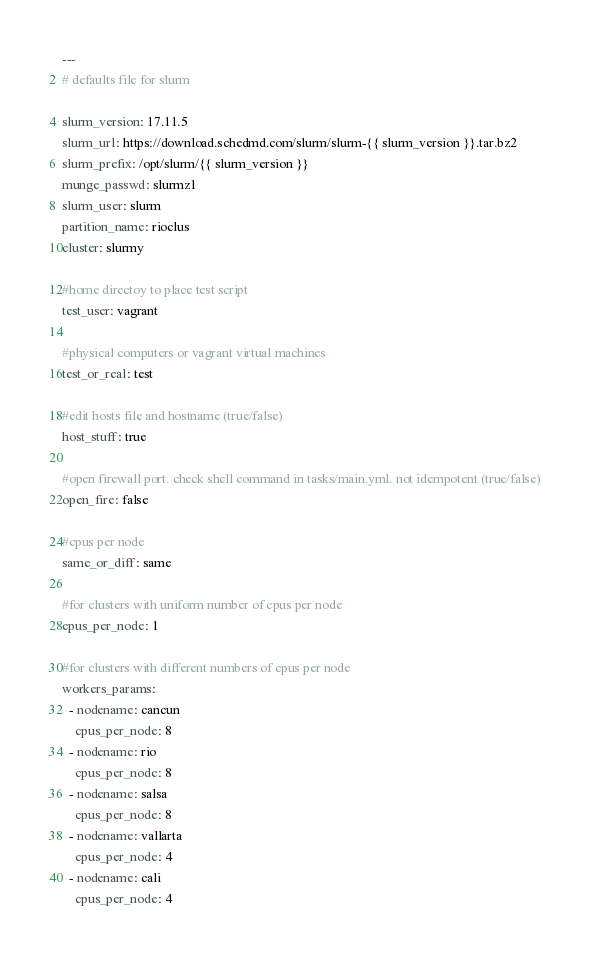<code> <loc_0><loc_0><loc_500><loc_500><_YAML_>---
# defaults file for slurm

slurm_version: 17.11.5
slurm_url: https://download.schedmd.com/slurm/slurm-{{ slurm_version }}.tar.bz2
slurm_prefix: /opt/slurm/{{ slurm_version }}
munge_passwd: slurmz1
slurm_user: slurm
partition_name: rioclus
cluster: slurmy

#home directoy to place test script
test_user: vagrant

#physical computers or vagrant virtual machines
test_or_real: test

#edit hosts file and hostname (true/false)
host_stuff: true

#open firewall port. check shell command in tasks/main.yml. not idempotent (true/false)
open_fire: false

#cpus per node
same_or_diff: same

#for clusters with uniform number of cpus per node
cpus_per_node: 1

#for clusters with different numbers of cpus per node
workers_params:
  - nodename: cancun
    cpus_per_node: 8
  - nodename: rio
    cpus_per_node: 8
  - nodename: salsa
    cpus_per_node: 8
  - nodename: vallarta
    cpus_per_node: 4
  - nodename: cali
    cpus_per_node: 4
</code> 